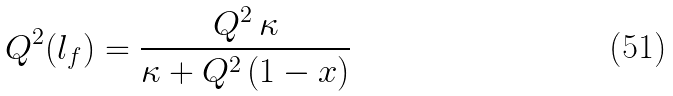<formula> <loc_0><loc_0><loc_500><loc_500>Q ^ { 2 } ( l _ { f } ) = \frac { Q ^ { 2 } \, \kappa } { \kappa + Q ^ { 2 } \, ( 1 - x ) }</formula> 